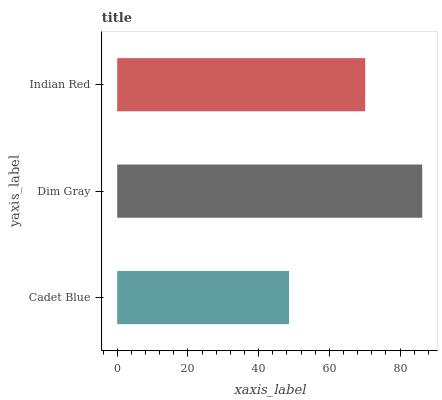Is Cadet Blue the minimum?
Answer yes or no. Yes. Is Dim Gray the maximum?
Answer yes or no. Yes. Is Indian Red the minimum?
Answer yes or no. No. Is Indian Red the maximum?
Answer yes or no. No. Is Dim Gray greater than Indian Red?
Answer yes or no. Yes. Is Indian Red less than Dim Gray?
Answer yes or no. Yes. Is Indian Red greater than Dim Gray?
Answer yes or no. No. Is Dim Gray less than Indian Red?
Answer yes or no. No. Is Indian Red the high median?
Answer yes or no. Yes. Is Indian Red the low median?
Answer yes or no. Yes. Is Cadet Blue the high median?
Answer yes or no. No. Is Dim Gray the low median?
Answer yes or no. No. 